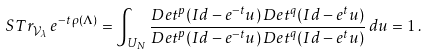<formula> <loc_0><loc_0><loc_500><loc_500>S T r _ { \mathcal { V } _ { \lambda } } \, e ^ { - t \, \rho ( \Lambda ) } = \int _ { U _ { N } } \frac { D e t ^ { p } ( I d - e ^ { - t } u ) \, D e t ^ { q } ( I d - e ^ { t } u ) } { D e t ^ { p } ( I d - e ^ { - t } u ) \, D e t ^ { q } ( I d - e ^ { t } u ) } \, d u = 1 \, .</formula> 